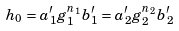<formula> <loc_0><loc_0><loc_500><loc_500>h _ { 0 } = a _ { 1 } ^ { \prime } g _ { 1 } ^ { n _ { 1 } } b _ { 1 } ^ { \prime } = a _ { 2 } ^ { \prime } g _ { 2 } ^ { n _ { 2 } } b _ { 2 } ^ { \prime }</formula> 